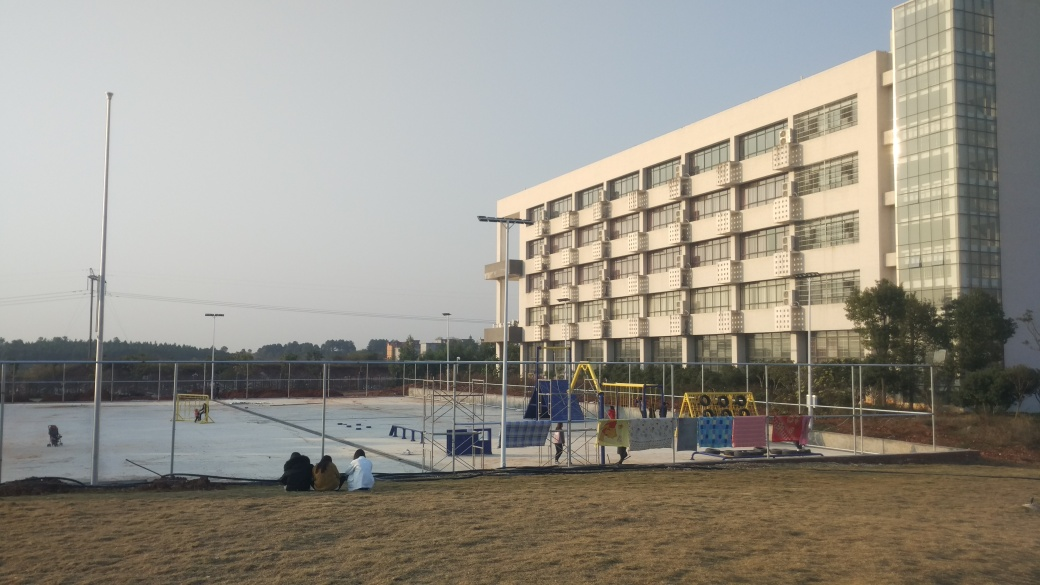Can you describe the overall atmosphere of this place? The overall atmosphere seems peaceful and leisurely. There's a sense of quiet activity, with space for both play and rest. The individuals sitting on the ground give a relaxed vibe, while the unoccupied playground equipment awaits more energetic play. The combination of open space for physical activities and the calm backdrop of the building create a balanced environment suitable for various age groups. 